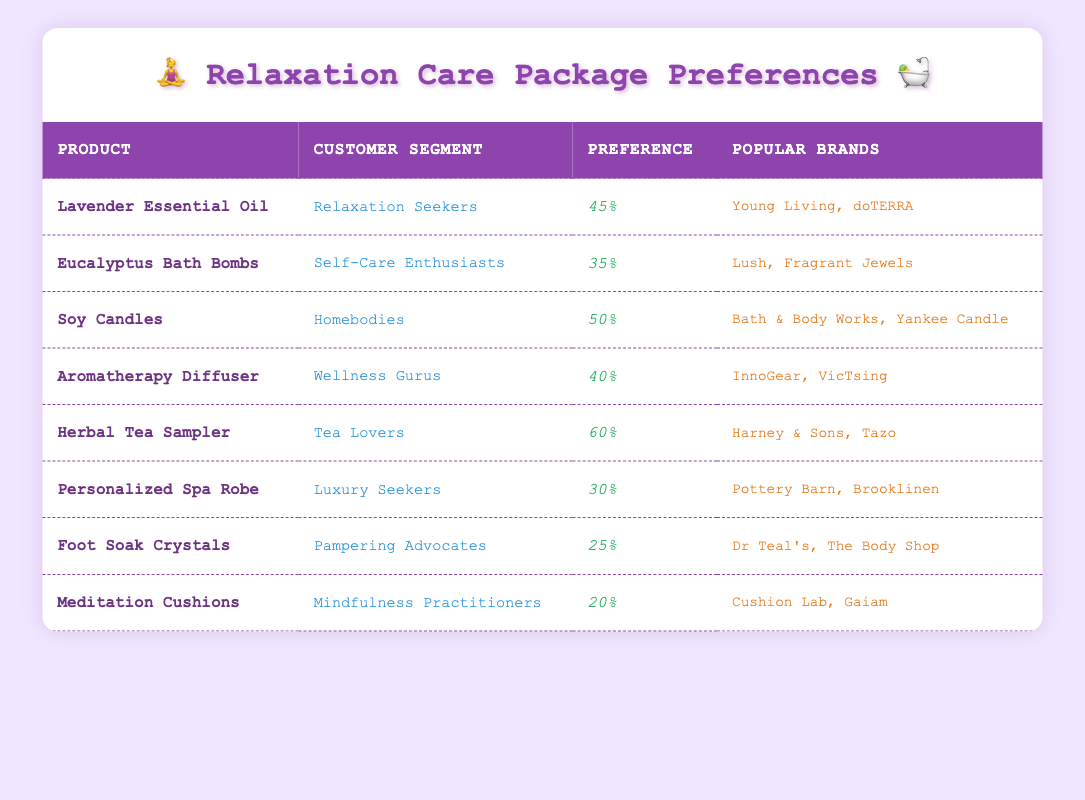What's the preference percentage for Lavender Essential Oil? The preference percentage for Lavender Essential Oil is listed in the corresponding row of the table and is 45%.
Answer: 45% Which product is most popular among Tea Lovers? Referring to the table, the product associated with Tea Lovers has a preference percentage of 60%, which is Herbal Tea Sampler.
Answer: Herbal Tea Sampler Are Aromatherapy Diffusers preferred more than Foot Soak Crystals? Comparing the preference percentages, Aromatherapy Diffusers have a 40% preference, while Foot Soak Crystals have a 25% preference. Since 40% is greater than 25%, Aromatherapy Diffusers are indeed preferred more.
Answer: Yes What is the average preference percentage of the products targeting Luxury Seekers and Pampering Advocates? The preference percentage for Luxury Seekers is 30% and for Pampering Advocates is 25%. Adding these gives 30 + 25 = 55. To find the average, divide by 2: 55 / 2 = 27.5.
Answer: 27.5 Is the preference percentage for Soy Candles the highest among Homebodies? The table shows a preference percentage of 50% for Soy Candles. Since no other products are listed for Homebodies, this is the only value and thus must be the highest.
Answer: Yes Which product has the lowest preference percentage and what is it? By scanning through the table, Foot Soak Crystals have the lowest preference percentage with a figure of 25%. This can be confirmed by comparing all listed products' preference percentages.
Answer: Foot Soak Crystals, 25% If we combine the preference percentages of Lavender Essential Oil and Aromatherapy Diffuser, what is the total? The preference percentage for Lavender Essential Oil is 45% and for Aromatherapy Diffuser it is 40%. Adding these two gives 45 + 40 = 85%.
Answer: 85% What percentage preference does the product Personalized Spa Robe have according to the table? The table specifically states that the Personalized Spa Robe has a preference percentage of 30%.
Answer: 30% 